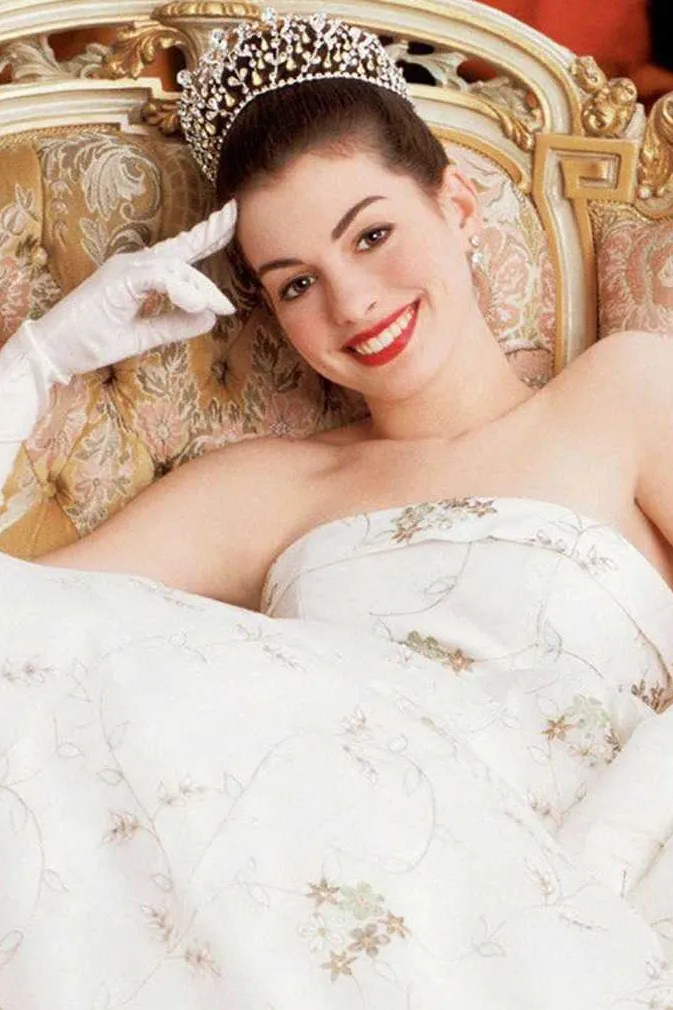Explain the visual content of the image in great detail. The image captures a young woman portrayed in a majestic setting. She is dressed in an elegant white strapless gown with intricate floral embroidery that gracefully spreads across the fabric. The gown itself subtly blends into the ornate cream-colored sofa she reclines on, featuring golden embellishments that echo the luxurious setting. On her head sits an elaborate diamond tiara, sparkling amidst her neatly styled updo. Adding a touch of sophistication, she wears pristine white gloves that highlight her delicate demeanor. Her smile exudes warmth and a sense of welcoming grace, while the overall ambiance of the setting, embellished with richly textured cushions and a classic backdrop, speaks volumes about the royal or high-society theme depicted here. 